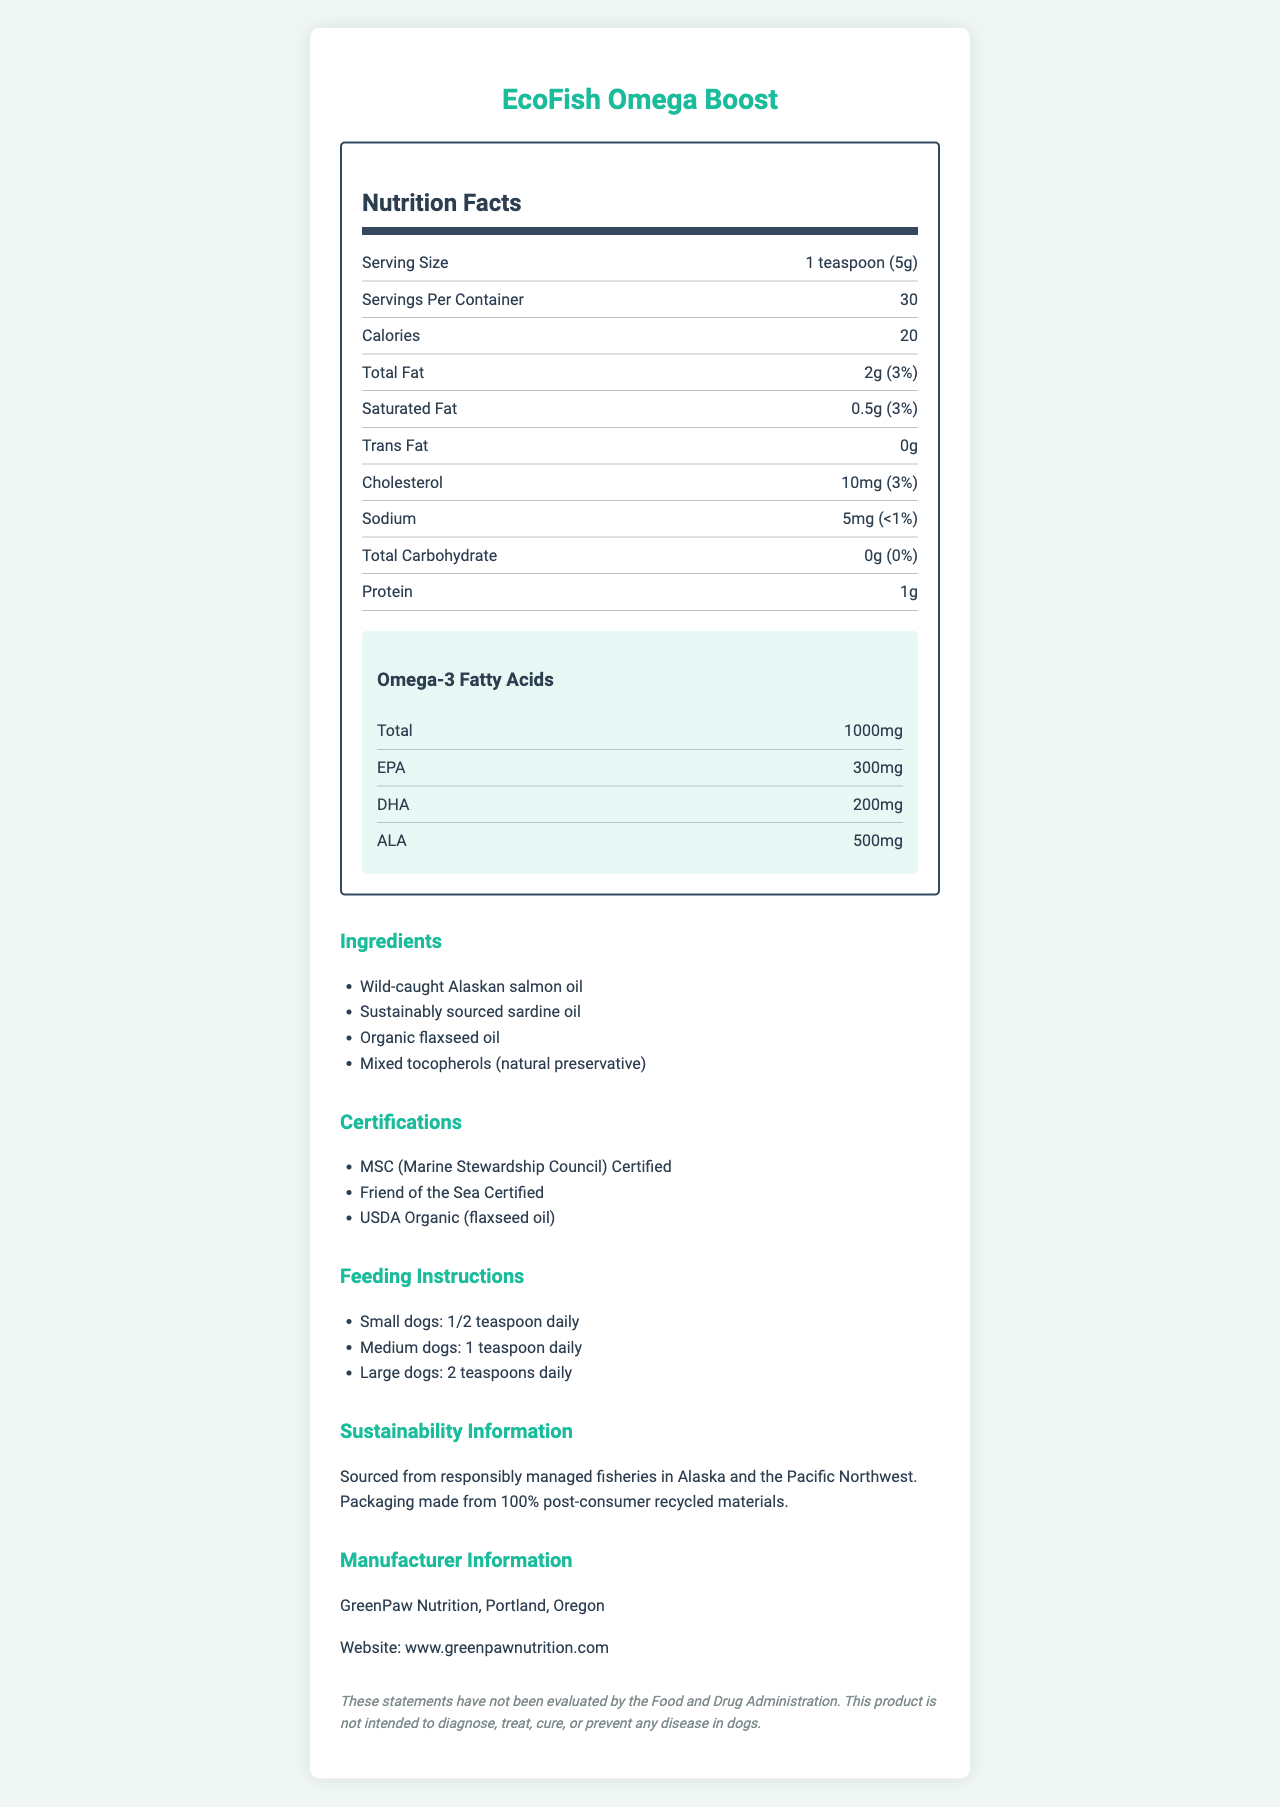what is the serving size for EcoFish Omega Boost? The serving size is listed at the beginning of the nutrition facts section.
Answer: 1 teaspoon (5g) how many servings are in one container? The document states that there are 30 servings per container.
Answer: 30 how many calories are in one serving? The number of calories per serving is stated as 20 calories.
Answer: 20 calories what types of omega-3 fatty acids are in this supplement and their amounts? The omega-3 breakdown includes EPA, DHA, and ALA with their specific amounts listed in the document.
Answer: EPA: 300mg, DHA: 200mg, ALA: 500mg what are the primary ingredients in this supplement? The ingredients list includes these four main components.
Answer: Wild-caught Alaskan salmon oil, sustainably sourced sardine oil, organic flaxseed oil, mixed tocopherols (natural preservative) how much total fat is in each serving? The total fat content and its daily value percentage are stated in the nutrition facts.
Answer: 2g (3% daily value) is there any trans fat in this supplement? The document lists the trans fat content as 0g.
Answer: No how much protein does each serving contain? The protein content per serving is listed as 1g.
Answer: 1g true or false: EcoFish Omega Boost contains gluten. The allergen information only mentions fish (salmon, sardine) and does not list gluten as an ingredient or allergen.
Answer: False summarize the key details of EcoFish Omega Boost in one sentence. This summary includes the product’s purpose, key ingredients, certifications, and manufacturing details.
Answer: EcoFish Omega Boost is a sustainable fish-based dog supplement providing omega-3 fatty acids (EPA, DHA, ALA), with ingredients like wild-caught Alaskan salmon oil and organic flaxseed oil, certified by MSC, Friend of the Sea, and USDA Organic, manufactured by GreenPaw Nutrition in Portland, Oregon. what company manufactures EcoFish Omega Boost, and where is it located? The manufacturer information section lists GreenPaw Nutrition and its location.
Answer: GreenPaw Nutrition, Portland, Oregon how much cholesterol is in one serving of EcoFish Omega Boost? The cholesterol content and its daily value percentage are listed in the nutrition facts.
Answer: 10mg (3% daily value) what is the feeding instruction for medium dogs? The feeding instructions section specifies that medium dogs should be given 1 teaspoon daily.
Answer: 1 teaspoon daily what is the website for GreenPaw Nutrition? The website is provided under the manufacturer information section.
Answer: www.greenpawnutrition.com how much calcium does the supplement contain? The nutrition facts list the calcium content as 1% of the daily value.
Answer: 1% do small dogs require more or less than 1 teaspoon daily of EcoFish Omega Boost? The feeding instructions state that small dogs require 1/2 teaspoon daily.
Answer: Less (1/2 teaspoon daily) is there any information on the benefits of omega-3 fatty acids in the document? The document lists the amounts but does not discuss the benefits of omega-3 fatty acids.
Answer: No 